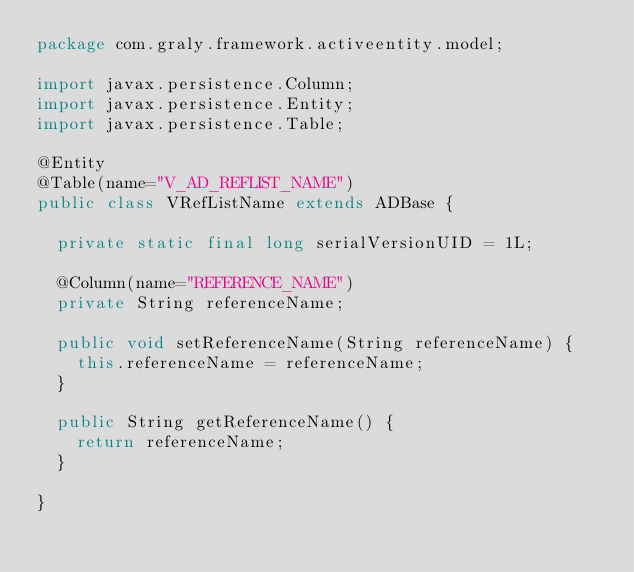Convert code to text. <code><loc_0><loc_0><loc_500><loc_500><_Java_>package com.graly.framework.activeentity.model;

import javax.persistence.Column;
import javax.persistence.Entity;
import javax.persistence.Table;

@Entity
@Table(name="V_AD_REFLIST_NAME")
public class VRefListName extends ADBase {
	
	private static final long serialVersionUID = 1L;
	
	@Column(name="REFERENCE_NAME")
	private String referenceName;

	public void setReferenceName(String referenceName) {
		this.referenceName = referenceName;
	}

	public String getReferenceName() {
		return referenceName;
	}

}
</code> 